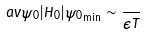Convert formula to latex. <formula><loc_0><loc_0><loc_500><loc_500>\ a v { \psi _ { 0 } | H _ { 0 } | \psi _ { 0 } } _ { \min } \sim \frac { } { \epsilon T }</formula> 